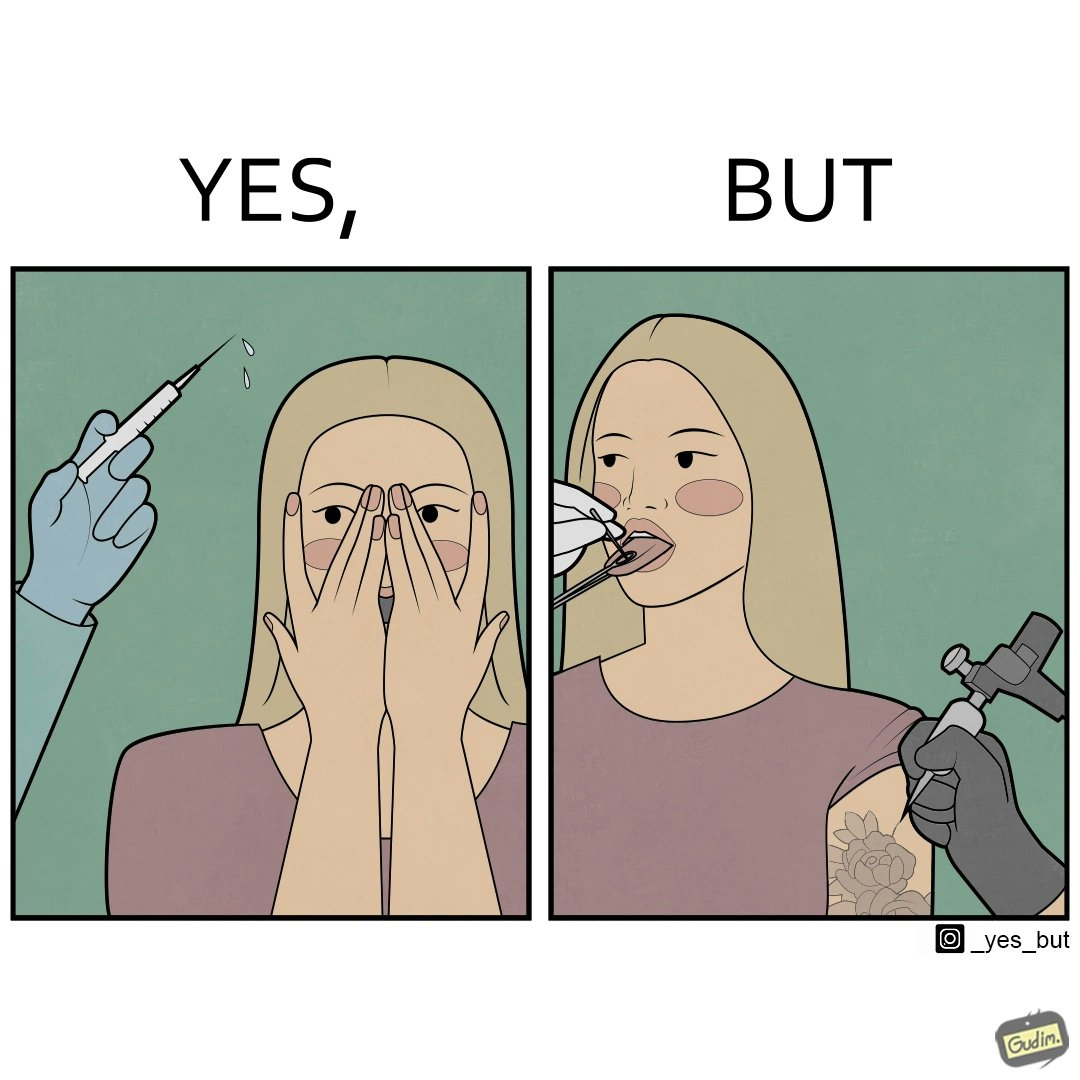Would you classify this image as satirical? Yes, this image is satirical. 